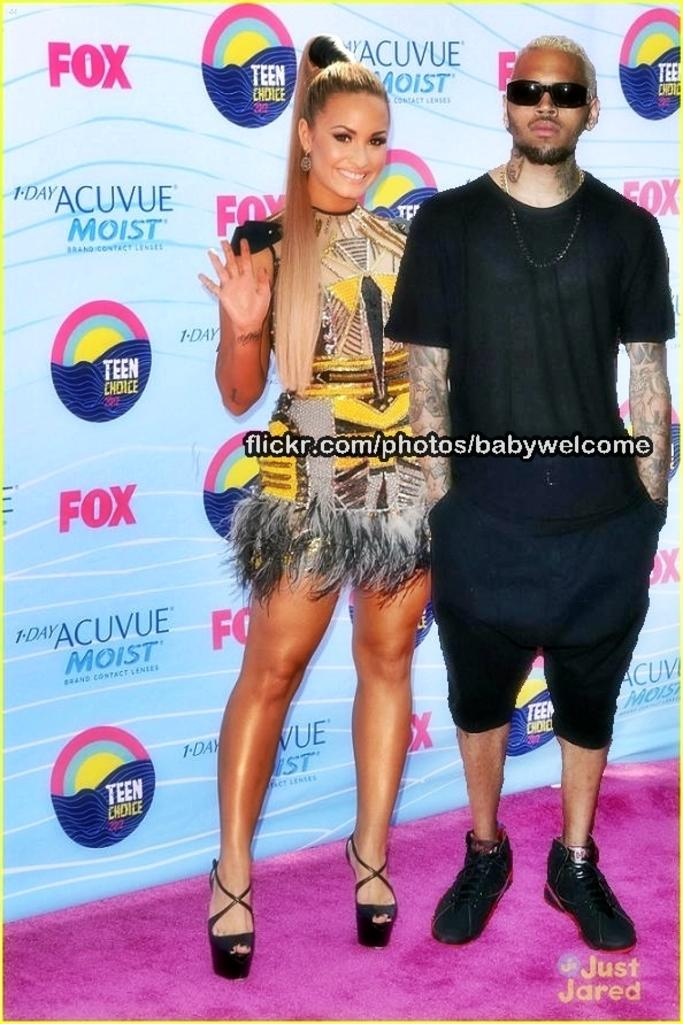What are the two people in the image? There is a man and a woman in the image. What is the woman doing in the image? The woman is standing in the image. What can be seen hanging or displayed in the image? There is a banner in the image. What is written or displayed on the banner? The banner has some text. What else is featured on the banner besides the text? The banner has a logo. What type of mint can be seen growing in the image? There is no mint plant present in the image. What is the kitten doing in the image? There is no kitten present in the image. What type of tub is visible in the image? There is no tub present in the image. 